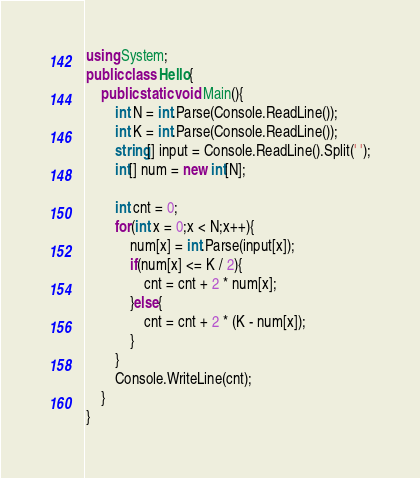<code> <loc_0><loc_0><loc_500><loc_500><_C#_>using System;
public class Hello{
    public static void Main(){
        int N = int.Parse(Console.ReadLine());
        int K = int.Parse(Console.ReadLine());
        string[] input = Console.ReadLine().Split(' ');
        int[] num = new int[N];
        
        int cnt = 0;
        for(int x = 0;x < N;x++){
            num[x] = int.Parse(input[x]);
            if(num[x] <= K / 2){
                cnt = cnt + 2 * num[x]; 
            }else{
                cnt = cnt + 2 * (K - num[x]);
            }
        }
        Console.WriteLine(cnt);
    }
}
</code> 